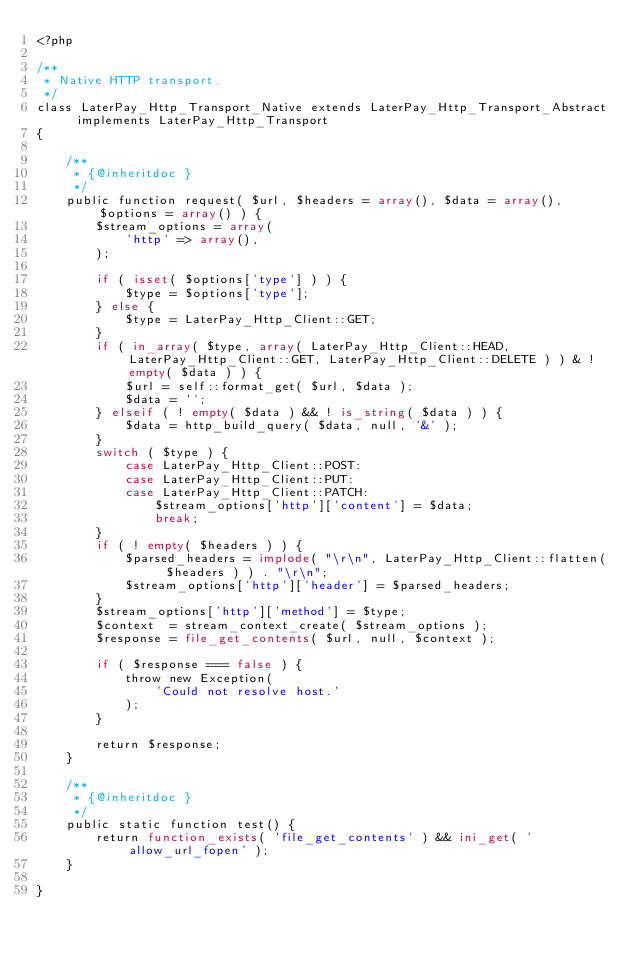Convert code to text. <code><loc_0><loc_0><loc_500><loc_500><_PHP_><?php

/**
 * Native HTTP transport.
 */
class LaterPay_Http_Transport_Native extends LaterPay_Http_Transport_Abstract implements LaterPay_Http_Transport
{

    /**
     * {@inheritdoc }
     */
    public function request( $url, $headers = array(), $data = array(), $options = array() ) {
        $stream_options = array(
            'http' => array(),
        );

        if ( isset( $options['type'] ) ) {
            $type = $options['type'];
        } else {
            $type = LaterPay_Http_Client::GET;
        }
        if ( in_array( $type, array( LaterPay_Http_Client::HEAD, LaterPay_Http_Client::GET, LaterPay_Http_Client::DELETE ) ) & ! empty( $data ) ) {
            $url = self::format_get( $url, $data );
            $data = '';
        } elseif ( ! empty( $data ) && ! is_string( $data ) ) {
            $data = http_build_query( $data, null, '&' );
        }
        switch ( $type ) {
            case LaterPay_Http_Client::POST:
            case LaterPay_Http_Client::PUT:
            case LaterPay_Http_Client::PATCH:
                $stream_options['http']['content'] = $data;
                break;
        }
        if ( ! empty( $headers ) ) {
            $parsed_headers = implode( "\r\n", LaterPay_Http_Client::flatten( $headers ) ) . "\r\n";
            $stream_options['http']['header'] = $parsed_headers;
        }
        $stream_options['http']['method'] = $type;
        $context  = stream_context_create( $stream_options );
        $response = file_get_contents( $url, null, $context );

        if ( $response === false ) {
            throw new Exception(
                'Could not resolve host.'
            );
        }

        return $response;
    }

    /**
     * {@inheritdoc }
     */
    public static function test() {
        return function_exists( 'file_get_contents' ) && ini_get( 'allow_url_fopen' );
    }

}
</code> 